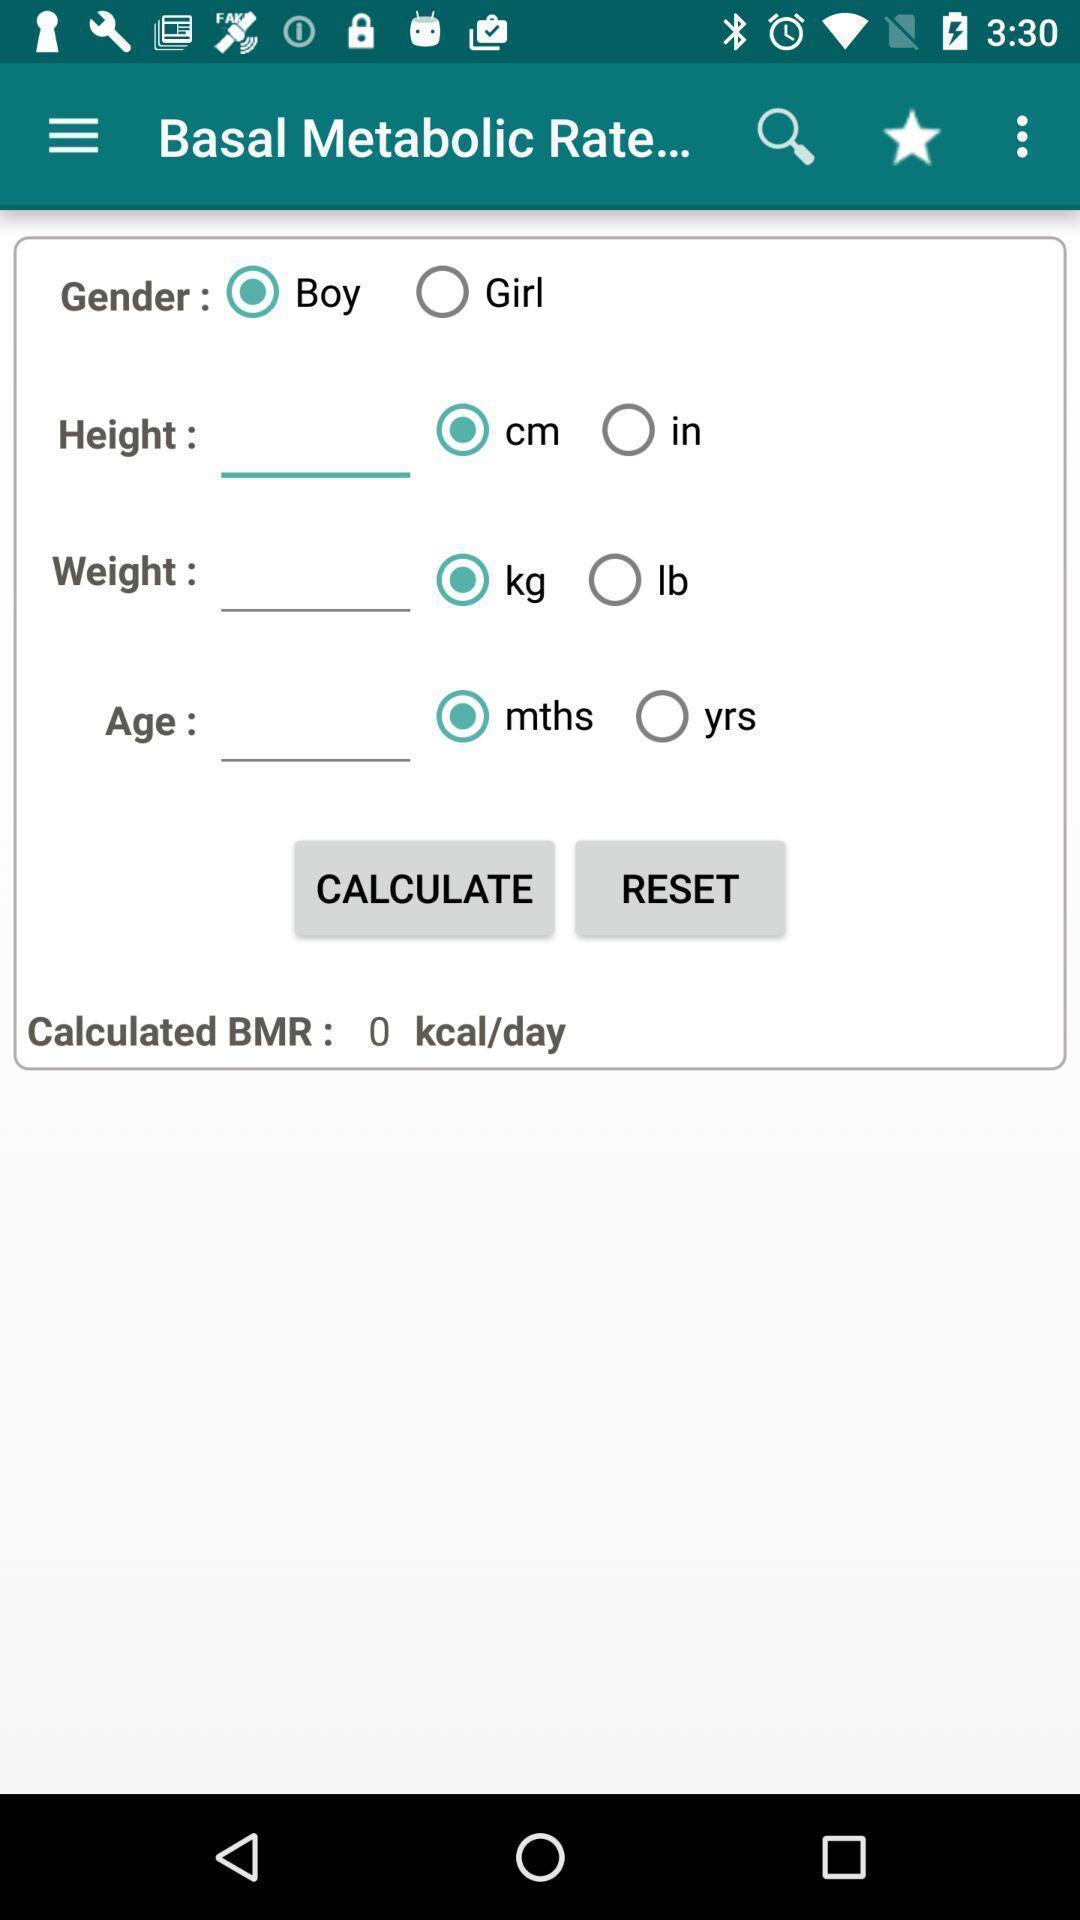Provide a description of this screenshot. Page shows the metabolic rate details on health app. 